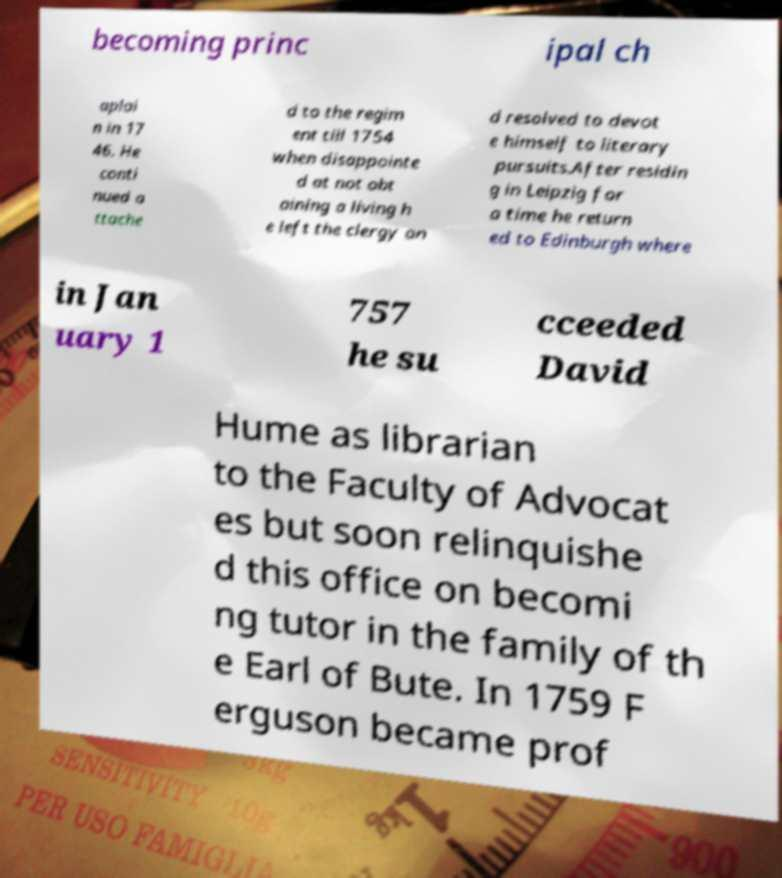Can you read and provide the text displayed in the image?This photo seems to have some interesting text. Can you extract and type it out for me? becoming princ ipal ch aplai n in 17 46. He conti nued a ttache d to the regim ent till 1754 when disappointe d at not obt aining a living h e left the clergy an d resolved to devot e himself to literary pursuits.After residin g in Leipzig for a time he return ed to Edinburgh where in Jan uary 1 757 he su cceeded David Hume as librarian to the Faculty of Advocat es but soon relinquishe d this office on becomi ng tutor in the family of th e Earl of Bute. In 1759 F erguson became prof 